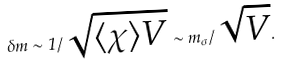Convert formula to latex. <formula><loc_0><loc_0><loc_500><loc_500>\delta m \sim 1 / \sqrt { \langle \chi \rangle V } \sim m _ { \sigma } / \sqrt { V } .</formula> 